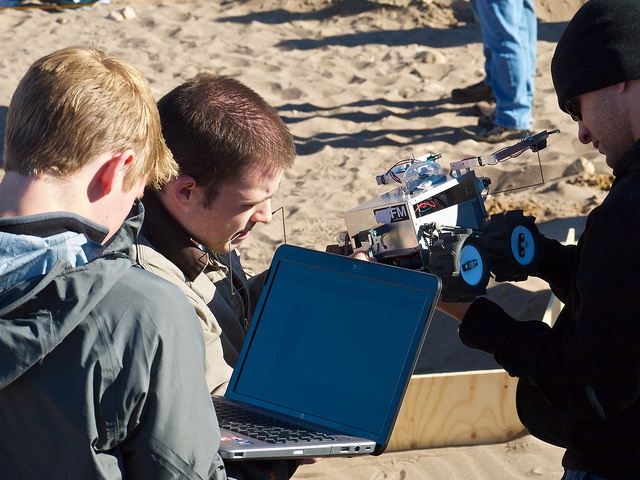Describe the objects in this image and their specific colors. I can see people in blue, black, darkgray, gray, and lightgray tones, people in blue, black, and brown tones, laptop in blue, darkblue, black, and gray tones, people in blue, black, brown, maroon, and ivory tones, and people in blue, navy, lightblue, darkblue, and black tones in this image. 